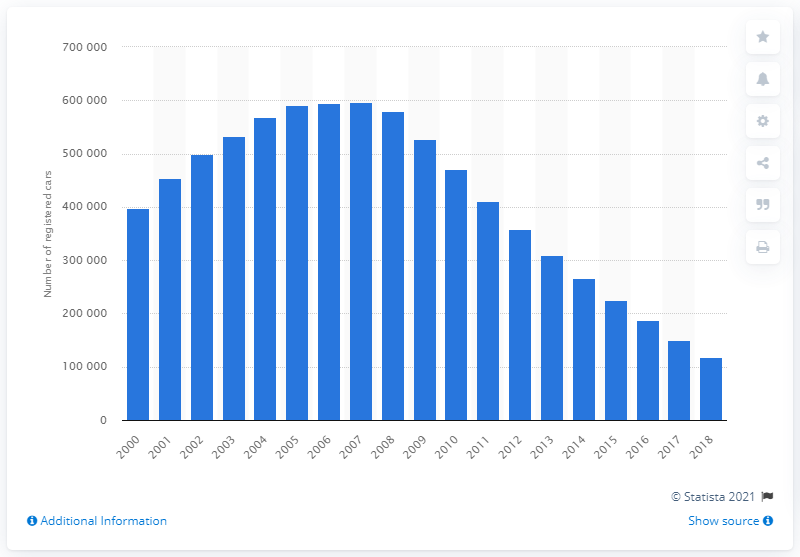Identify some key points in this picture. The last quarter of 2018 occurred in approximately 2000. In 2018, a total of 117,962 cars were registered in Britain. 